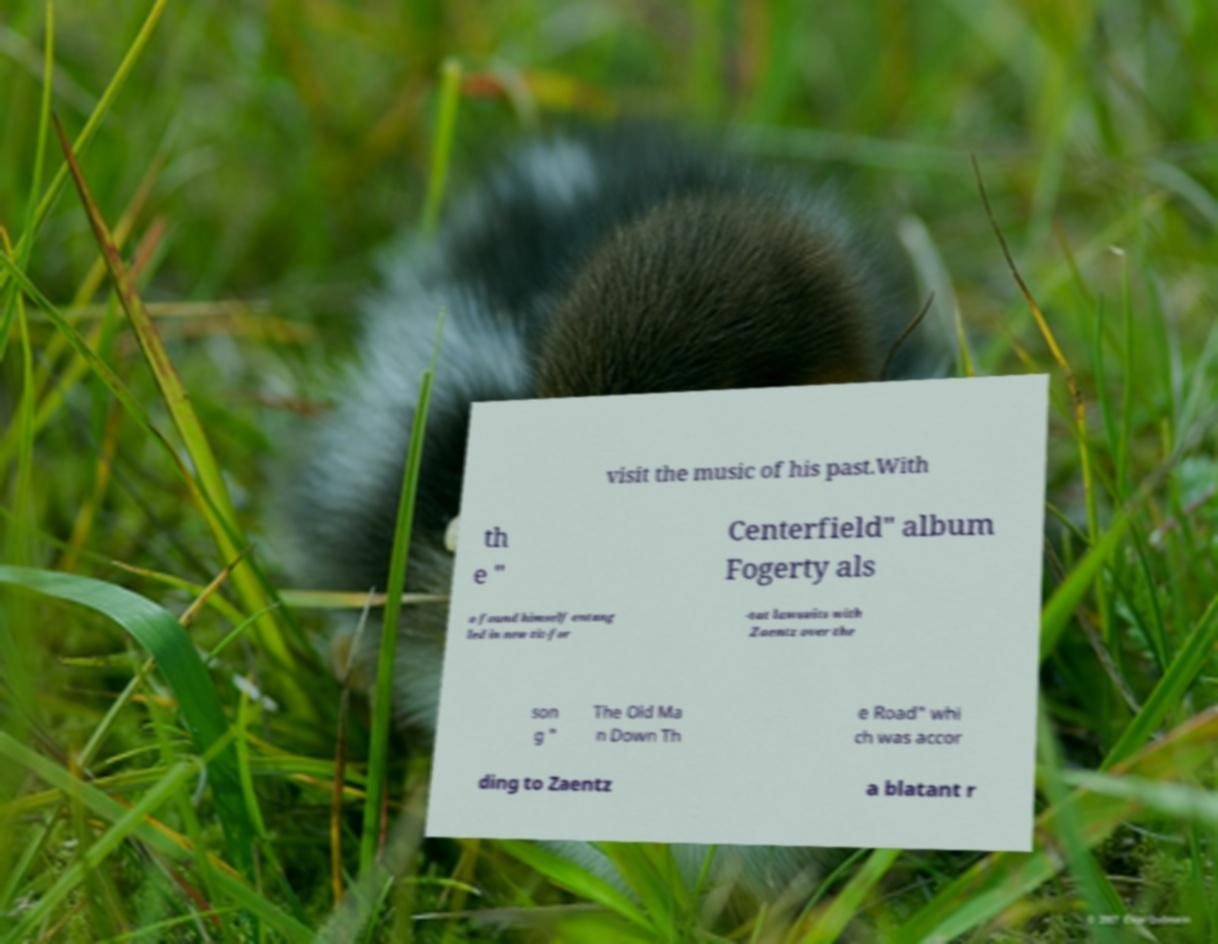For documentation purposes, I need the text within this image transcribed. Could you provide that? visit the music of his past.With th e " Centerfield" album Fogerty als o found himself entang led in new tit-for -tat lawsuits with Zaentz over the son g " The Old Ma n Down Th e Road" whi ch was accor ding to Zaentz a blatant r 